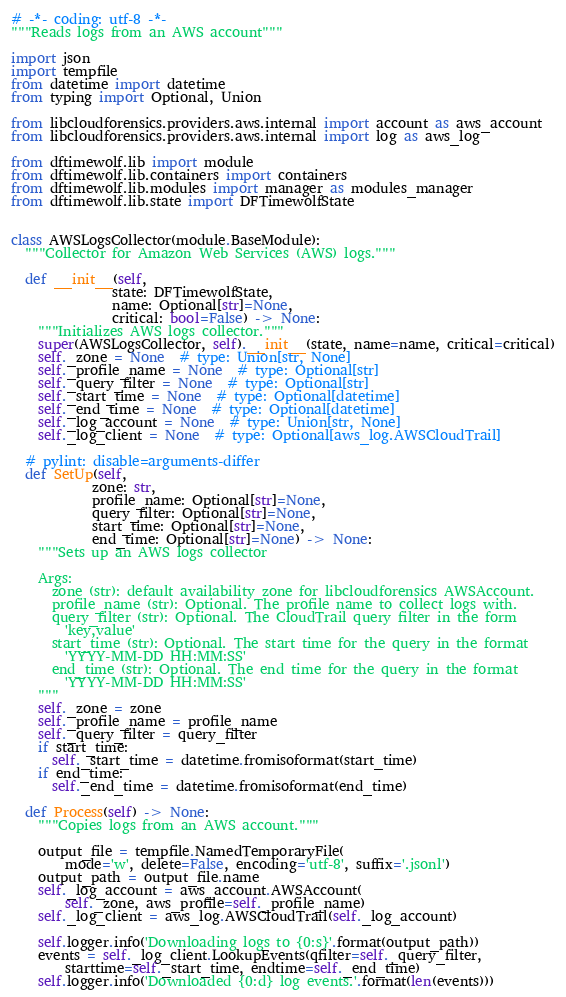Convert code to text. <code><loc_0><loc_0><loc_500><loc_500><_Python_># -*- coding: utf-8 -*-
"""Reads logs from an AWS account"""

import json
import tempfile
from datetime import datetime
from typing import Optional, Union

from libcloudforensics.providers.aws.internal import account as aws_account
from libcloudforensics.providers.aws.internal import log as aws_log

from dftimewolf.lib import module
from dftimewolf.lib.containers import containers
from dftimewolf.lib.modules import manager as modules_manager
from dftimewolf.lib.state import DFTimewolfState


class AWSLogsCollector(module.BaseModule):
  """Collector for Amazon Web Services (AWS) logs."""

  def __init__(self,
               state: DFTimewolfState,
               name: Optional[str]=None,
               critical: bool=False) -> None:
    """Initializes AWS logs collector."""
    super(AWSLogsCollector, self).__init__(state, name=name, critical=critical)
    self._zone = None  # type: Union[str, None]
    self._profile_name = None  # type: Optional[str]
    self._query_filter = None  # type: Optional[str]
    self._start_time = None  # type: Optional[datetime]
    self._end_time = None  # type: Optional[datetime]
    self._log_account = None  # type: Union[str, None]
    self._log_client = None  # type: Optional[aws_log.AWSCloudTrail]

  # pylint: disable=arguments-differ
  def SetUp(self,
            zone: str,
            profile_name: Optional[str]=None,
            query_filter: Optional[str]=None,
            start_time: Optional[str]=None,
            end_time: Optional[str]=None) -> None:
    """Sets up an AWS logs collector

    Args:
      zone (str): default availability zone for libcloudforensics AWSAccount.
      profile_name (str): Optional. The profile name to collect logs with.
      query_filter (str): Optional. The CloudTrail query filter in the form
        'key,value'
      start_time (str): Optional. The start time for the query in the format
        'YYYY-MM-DD HH:MM:SS'
      end_time (str): Optional. The end time for the query in the format
        'YYYY-MM-DD HH:MM:SS'
    """
    self._zone = zone
    self._profile_name = profile_name
    self._query_filter = query_filter
    if start_time:
      self._start_time = datetime.fromisoformat(start_time)
    if end_time:
      self._end_time = datetime.fromisoformat(end_time)

  def Process(self) -> None:
    """Copies logs from an AWS account."""

    output_file = tempfile.NamedTemporaryFile(
        mode='w', delete=False, encoding='utf-8', suffix='.jsonl')
    output_path = output_file.name
    self._log_account = aws_account.AWSAccount(
        self._zone, aws_profile=self._profile_name)
    self._log_client = aws_log.AWSCloudTrail(self._log_account)

    self.logger.info('Downloading logs to {0:s}'.format(output_path))
    events = self._log_client.LookupEvents(qfilter=self._query_filter,
        starttime=self._start_time, endtime=self._end_time)
    self.logger.info('Downloaded {0:d} log events.'.format(len(events)))
</code> 